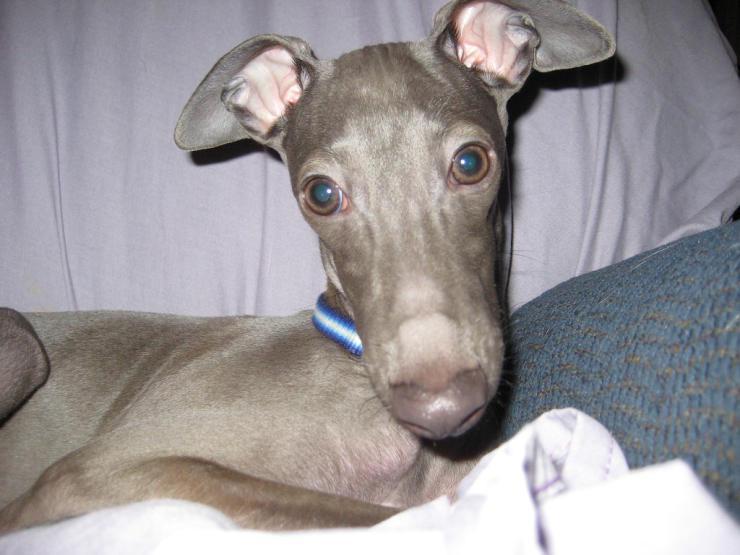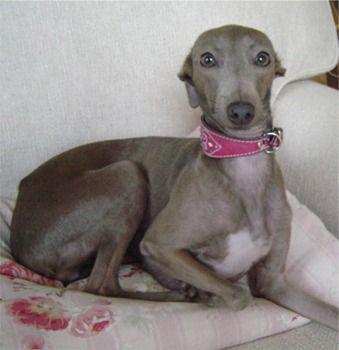The first image is the image on the left, the second image is the image on the right. Given the left and right images, does the statement "There are no more than two Italian greyhounds, all wearing collars." hold true? Answer yes or no. Yes. The first image is the image on the left, the second image is the image on the right. For the images displayed, is the sentence "There are four dogs." factually correct? Answer yes or no. No. 